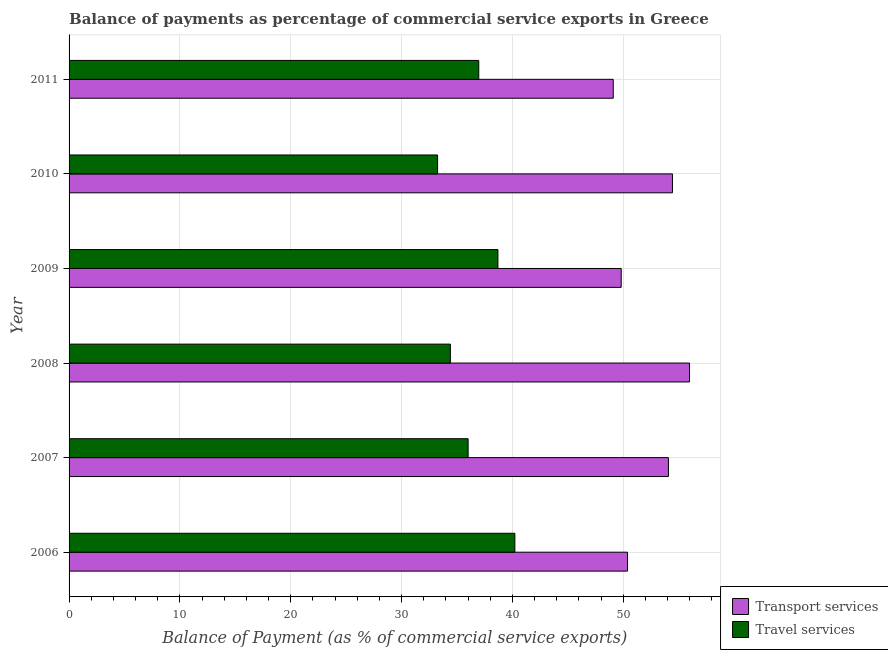How many different coloured bars are there?
Offer a terse response. 2. How many bars are there on the 6th tick from the bottom?
Your response must be concise. 2. What is the balance of payments of transport services in 2006?
Provide a succinct answer. 50.38. Across all years, what is the maximum balance of payments of transport services?
Make the answer very short. 55.97. Across all years, what is the minimum balance of payments of travel services?
Your answer should be very brief. 33.25. In which year was the balance of payments of travel services maximum?
Your response must be concise. 2006. What is the total balance of payments of transport services in the graph?
Your answer should be very brief. 313.76. What is the difference between the balance of payments of travel services in 2007 and that in 2010?
Offer a terse response. 2.75. What is the difference between the balance of payments of transport services in 2011 and the balance of payments of travel services in 2006?
Provide a short and direct response. 8.88. What is the average balance of payments of transport services per year?
Keep it short and to the point. 52.29. In the year 2009, what is the difference between the balance of payments of transport services and balance of payments of travel services?
Give a very brief answer. 11.12. In how many years, is the balance of payments of transport services greater than 10 %?
Your response must be concise. 6. What is the ratio of the balance of payments of travel services in 2010 to that in 2011?
Your answer should be compact. 0.9. What is the difference between the highest and the second highest balance of payments of travel services?
Offer a very short reply. 1.53. What is the difference between the highest and the lowest balance of payments of transport services?
Offer a very short reply. 6.88. What does the 2nd bar from the top in 2010 represents?
Offer a terse response. Transport services. What does the 2nd bar from the bottom in 2009 represents?
Give a very brief answer. Travel services. Are all the bars in the graph horizontal?
Provide a succinct answer. Yes. How many years are there in the graph?
Provide a succinct answer. 6. What is the difference between two consecutive major ticks on the X-axis?
Provide a succinct answer. 10. Does the graph contain any zero values?
Give a very brief answer. No. Where does the legend appear in the graph?
Offer a terse response. Bottom right. How many legend labels are there?
Offer a very short reply. 2. What is the title of the graph?
Ensure brevity in your answer.  Balance of payments as percentage of commercial service exports in Greece. Does "Net National savings" appear as one of the legend labels in the graph?
Make the answer very short. No. What is the label or title of the X-axis?
Make the answer very short. Balance of Payment (as % of commercial service exports). What is the label or title of the Y-axis?
Your answer should be very brief. Year. What is the Balance of Payment (as % of commercial service exports) in Transport services in 2006?
Offer a terse response. 50.38. What is the Balance of Payment (as % of commercial service exports) in Travel services in 2006?
Ensure brevity in your answer.  40.22. What is the Balance of Payment (as % of commercial service exports) of Transport services in 2007?
Ensure brevity in your answer.  54.07. What is the Balance of Payment (as % of commercial service exports) in Travel services in 2007?
Offer a terse response. 36. What is the Balance of Payment (as % of commercial service exports) in Transport services in 2008?
Ensure brevity in your answer.  55.97. What is the Balance of Payment (as % of commercial service exports) of Travel services in 2008?
Give a very brief answer. 34.4. What is the Balance of Payment (as % of commercial service exports) in Transport services in 2009?
Keep it short and to the point. 49.81. What is the Balance of Payment (as % of commercial service exports) of Travel services in 2009?
Keep it short and to the point. 38.69. What is the Balance of Payment (as % of commercial service exports) of Transport services in 2010?
Your response must be concise. 54.43. What is the Balance of Payment (as % of commercial service exports) in Travel services in 2010?
Your answer should be compact. 33.25. What is the Balance of Payment (as % of commercial service exports) of Transport services in 2011?
Offer a very short reply. 49.09. What is the Balance of Payment (as % of commercial service exports) of Travel services in 2011?
Make the answer very short. 36.96. Across all years, what is the maximum Balance of Payment (as % of commercial service exports) in Transport services?
Offer a terse response. 55.97. Across all years, what is the maximum Balance of Payment (as % of commercial service exports) of Travel services?
Give a very brief answer. 40.22. Across all years, what is the minimum Balance of Payment (as % of commercial service exports) in Transport services?
Provide a succinct answer. 49.09. Across all years, what is the minimum Balance of Payment (as % of commercial service exports) of Travel services?
Ensure brevity in your answer.  33.25. What is the total Balance of Payment (as % of commercial service exports) of Transport services in the graph?
Offer a terse response. 313.76. What is the total Balance of Payment (as % of commercial service exports) of Travel services in the graph?
Your answer should be very brief. 219.51. What is the difference between the Balance of Payment (as % of commercial service exports) in Transport services in 2006 and that in 2007?
Give a very brief answer. -3.69. What is the difference between the Balance of Payment (as % of commercial service exports) of Travel services in 2006 and that in 2007?
Offer a very short reply. 4.22. What is the difference between the Balance of Payment (as % of commercial service exports) in Transport services in 2006 and that in 2008?
Provide a short and direct response. -5.59. What is the difference between the Balance of Payment (as % of commercial service exports) in Travel services in 2006 and that in 2008?
Keep it short and to the point. 5.82. What is the difference between the Balance of Payment (as % of commercial service exports) in Transport services in 2006 and that in 2009?
Provide a short and direct response. 0.57. What is the difference between the Balance of Payment (as % of commercial service exports) of Travel services in 2006 and that in 2009?
Ensure brevity in your answer.  1.53. What is the difference between the Balance of Payment (as % of commercial service exports) in Transport services in 2006 and that in 2010?
Your answer should be compact. -4.05. What is the difference between the Balance of Payment (as % of commercial service exports) in Travel services in 2006 and that in 2010?
Give a very brief answer. 6.97. What is the difference between the Balance of Payment (as % of commercial service exports) in Transport services in 2006 and that in 2011?
Provide a short and direct response. 1.29. What is the difference between the Balance of Payment (as % of commercial service exports) in Travel services in 2006 and that in 2011?
Ensure brevity in your answer.  3.26. What is the difference between the Balance of Payment (as % of commercial service exports) in Transport services in 2007 and that in 2008?
Provide a short and direct response. -1.9. What is the difference between the Balance of Payment (as % of commercial service exports) in Travel services in 2007 and that in 2008?
Your answer should be very brief. 1.6. What is the difference between the Balance of Payment (as % of commercial service exports) of Transport services in 2007 and that in 2009?
Your answer should be compact. 4.26. What is the difference between the Balance of Payment (as % of commercial service exports) in Travel services in 2007 and that in 2009?
Give a very brief answer. -2.69. What is the difference between the Balance of Payment (as % of commercial service exports) of Transport services in 2007 and that in 2010?
Your response must be concise. -0.36. What is the difference between the Balance of Payment (as % of commercial service exports) in Travel services in 2007 and that in 2010?
Give a very brief answer. 2.75. What is the difference between the Balance of Payment (as % of commercial service exports) in Transport services in 2007 and that in 2011?
Provide a succinct answer. 4.98. What is the difference between the Balance of Payment (as % of commercial service exports) of Travel services in 2007 and that in 2011?
Provide a short and direct response. -0.96. What is the difference between the Balance of Payment (as % of commercial service exports) in Transport services in 2008 and that in 2009?
Make the answer very short. 6.16. What is the difference between the Balance of Payment (as % of commercial service exports) in Travel services in 2008 and that in 2009?
Give a very brief answer. -4.29. What is the difference between the Balance of Payment (as % of commercial service exports) of Transport services in 2008 and that in 2010?
Make the answer very short. 1.54. What is the difference between the Balance of Payment (as % of commercial service exports) of Travel services in 2008 and that in 2010?
Your answer should be very brief. 1.15. What is the difference between the Balance of Payment (as % of commercial service exports) in Transport services in 2008 and that in 2011?
Make the answer very short. 6.88. What is the difference between the Balance of Payment (as % of commercial service exports) in Travel services in 2008 and that in 2011?
Provide a short and direct response. -2.56. What is the difference between the Balance of Payment (as % of commercial service exports) in Transport services in 2009 and that in 2010?
Keep it short and to the point. -4.62. What is the difference between the Balance of Payment (as % of commercial service exports) of Travel services in 2009 and that in 2010?
Provide a succinct answer. 5.44. What is the difference between the Balance of Payment (as % of commercial service exports) of Transport services in 2009 and that in 2011?
Offer a very short reply. 0.72. What is the difference between the Balance of Payment (as % of commercial service exports) of Travel services in 2009 and that in 2011?
Your answer should be compact. 1.73. What is the difference between the Balance of Payment (as % of commercial service exports) in Transport services in 2010 and that in 2011?
Ensure brevity in your answer.  5.34. What is the difference between the Balance of Payment (as % of commercial service exports) in Travel services in 2010 and that in 2011?
Your response must be concise. -3.72. What is the difference between the Balance of Payment (as % of commercial service exports) in Transport services in 2006 and the Balance of Payment (as % of commercial service exports) in Travel services in 2007?
Your answer should be very brief. 14.38. What is the difference between the Balance of Payment (as % of commercial service exports) in Transport services in 2006 and the Balance of Payment (as % of commercial service exports) in Travel services in 2008?
Your answer should be very brief. 15.98. What is the difference between the Balance of Payment (as % of commercial service exports) of Transport services in 2006 and the Balance of Payment (as % of commercial service exports) of Travel services in 2009?
Provide a short and direct response. 11.69. What is the difference between the Balance of Payment (as % of commercial service exports) in Transport services in 2006 and the Balance of Payment (as % of commercial service exports) in Travel services in 2010?
Ensure brevity in your answer.  17.14. What is the difference between the Balance of Payment (as % of commercial service exports) in Transport services in 2006 and the Balance of Payment (as % of commercial service exports) in Travel services in 2011?
Offer a terse response. 13.42. What is the difference between the Balance of Payment (as % of commercial service exports) of Transport services in 2007 and the Balance of Payment (as % of commercial service exports) of Travel services in 2008?
Keep it short and to the point. 19.67. What is the difference between the Balance of Payment (as % of commercial service exports) of Transport services in 2007 and the Balance of Payment (as % of commercial service exports) of Travel services in 2009?
Offer a terse response. 15.38. What is the difference between the Balance of Payment (as % of commercial service exports) of Transport services in 2007 and the Balance of Payment (as % of commercial service exports) of Travel services in 2010?
Provide a short and direct response. 20.83. What is the difference between the Balance of Payment (as % of commercial service exports) in Transport services in 2007 and the Balance of Payment (as % of commercial service exports) in Travel services in 2011?
Offer a very short reply. 17.11. What is the difference between the Balance of Payment (as % of commercial service exports) of Transport services in 2008 and the Balance of Payment (as % of commercial service exports) of Travel services in 2009?
Provide a short and direct response. 17.29. What is the difference between the Balance of Payment (as % of commercial service exports) in Transport services in 2008 and the Balance of Payment (as % of commercial service exports) in Travel services in 2010?
Provide a succinct answer. 22.73. What is the difference between the Balance of Payment (as % of commercial service exports) of Transport services in 2008 and the Balance of Payment (as % of commercial service exports) of Travel services in 2011?
Offer a terse response. 19.01. What is the difference between the Balance of Payment (as % of commercial service exports) of Transport services in 2009 and the Balance of Payment (as % of commercial service exports) of Travel services in 2010?
Keep it short and to the point. 16.57. What is the difference between the Balance of Payment (as % of commercial service exports) of Transport services in 2009 and the Balance of Payment (as % of commercial service exports) of Travel services in 2011?
Your response must be concise. 12.85. What is the difference between the Balance of Payment (as % of commercial service exports) in Transport services in 2010 and the Balance of Payment (as % of commercial service exports) in Travel services in 2011?
Ensure brevity in your answer.  17.47. What is the average Balance of Payment (as % of commercial service exports) of Transport services per year?
Your response must be concise. 52.29. What is the average Balance of Payment (as % of commercial service exports) of Travel services per year?
Your response must be concise. 36.58. In the year 2006, what is the difference between the Balance of Payment (as % of commercial service exports) of Transport services and Balance of Payment (as % of commercial service exports) of Travel services?
Your response must be concise. 10.16. In the year 2007, what is the difference between the Balance of Payment (as % of commercial service exports) of Transport services and Balance of Payment (as % of commercial service exports) of Travel services?
Provide a short and direct response. 18.07. In the year 2008, what is the difference between the Balance of Payment (as % of commercial service exports) in Transport services and Balance of Payment (as % of commercial service exports) in Travel services?
Make the answer very short. 21.58. In the year 2009, what is the difference between the Balance of Payment (as % of commercial service exports) in Transport services and Balance of Payment (as % of commercial service exports) in Travel services?
Provide a short and direct response. 11.12. In the year 2010, what is the difference between the Balance of Payment (as % of commercial service exports) in Transport services and Balance of Payment (as % of commercial service exports) in Travel services?
Your answer should be compact. 21.19. In the year 2011, what is the difference between the Balance of Payment (as % of commercial service exports) in Transport services and Balance of Payment (as % of commercial service exports) in Travel services?
Provide a short and direct response. 12.13. What is the ratio of the Balance of Payment (as % of commercial service exports) of Transport services in 2006 to that in 2007?
Ensure brevity in your answer.  0.93. What is the ratio of the Balance of Payment (as % of commercial service exports) of Travel services in 2006 to that in 2007?
Give a very brief answer. 1.12. What is the ratio of the Balance of Payment (as % of commercial service exports) of Transport services in 2006 to that in 2008?
Offer a terse response. 0.9. What is the ratio of the Balance of Payment (as % of commercial service exports) in Travel services in 2006 to that in 2008?
Ensure brevity in your answer.  1.17. What is the ratio of the Balance of Payment (as % of commercial service exports) in Transport services in 2006 to that in 2009?
Keep it short and to the point. 1.01. What is the ratio of the Balance of Payment (as % of commercial service exports) in Travel services in 2006 to that in 2009?
Your response must be concise. 1.04. What is the ratio of the Balance of Payment (as % of commercial service exports) of Transport services in 2006 to that in 2010?
Your response must be concise. 0.93. What is the ratio of the Balance of Payment (as % of commercial service exports) of Travel services in 2006 to that in 2010?
Make the answer very short. 1.21. What is the ratio of the Balance of Payment (as % of commercial service exports) in Transport services in 2006 to that in 2011?
Your answer should be compact. 1.03. What is the ratio of the Balance of Payment (as % of commercial service exports) of Travel services in 2006 to that in 2011?
Your answer should be very brief. 1.09. What is the ratio of the Balance of Payment (as % of commercial service exports) of Travel services in 2007 to that in 2008?
Your response must be concise. 1.05. What is the ratio of the Balance of Payment (as % of commercial service exports) in Transport services in 2007 to that in 2009?
Your answer should be very brief. 1.09. What is the ratio of the Balance of Payment (as % of commercial service exports) of Travel services in 2007 to that in 2009?
Offer a terse response. 0.93. What is the ratio of the Balance of Payment (as % of commercial service exports) of Travel services in 2007 to that in 2010?
Provide a succinct answer. 1.08. What is the ratio of the Balance of Payment (as % of commercial service exports) of Transport services in 2007 to that in 2011?
Provide a short and direct response. 1.1. What is the ratio of the Balance of Payment (as % of commercial service exports) of Travel services in 2007 to that in 2011?
Provide a succinct answer. 0.97. What is the ratio of the Balance of Payment (as % of commercial service exports) in Transport services in 2008 to that in 2009?
Give a very brief answer. 1.12. What is the ratio of the Balance of Payment (as % of commercial service exports) in Travel services in 2008 to that in 2009?
Offer a terse response. 0.89. What is the ratio of the Balance of Payment (as % of commercial service exports) in Transport services in 2008 to that in 2010?
Provide a short and direct response. 1.03. What is the ratio of the Balance of Payment (as % of commercial service exports) in Travel services in 2008 to that in 2010?
Your response must be concise. 1.03. What is the ratio of the Balance of Payment (as % of commercial service exports) of Transport services in 2008 to that in 2011?
Your answer should be very brief. 1.14. What is the ratio of the Balance of Payment (as % of commercial service exports) of Travel services in 2008 to that in 2011?
Provide a short and direct response. 0.93. What is the ratio of the Balance of Payment (as % of commercial service exports) of Transport services in 2009 to that in 2010?
Ensure brevity in your answer.  0.92. What is the ratio of the Balance of Payment (as % of commercial service exports) in Travel services in 2009 to that in 2010?
Make the answer very short. 1.16. What is the ratio of the Balance of Payment (as % of commercial service exports) of Transport services in 2009 to that in 2011?
Your answer should be very brief. 1.01. What is the ratio of the Balance of Payment (as % of commercial service exports) of Travel services in 2009 to that in 2011?
Offer a terse response. 1.05. What is the ratio of the Balance of Payment (as % of commercial service exports) in Transport services in 2010 to that in 2011?
Your answer should be compact. 1.11. What is the ratio of the Balance of Payment (as % of commercial service exports) in Travel services in 2010 to that in 2011?
Your answer should be compact. 0.9. What is the difference between the highest and the second highest Balance of Payment (as % of commercial service exports) in Transport services?
Your answer should be compact. 1.54. What is the difference between the highest and the second highest Balance of Payment (as % of commercial service exports) in Travel services?
Provide a succinct answer. 1.53. What is the difference between the highest and the lowest Balance of Payment (as % of commercial service exports) of Transport services?
Your response must be concise. 6.88. What is the difference between the highest and the lowest Balance of Payment (as % of commercial service exports) in Travel services?
Provide a short and direct response. 6.97. 